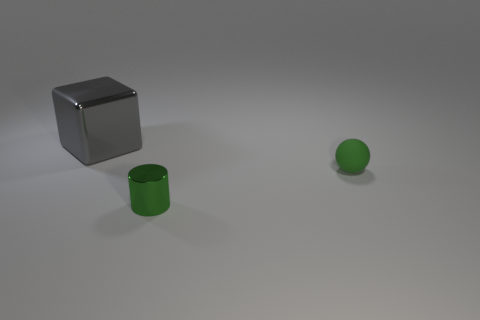Add 2 rubber balls. How many objects exist? 5 Subtract all balls. How many objects are left? 2 Subtract all gray cubes. Subtract all purple things. How many objects are left? 2 Add 2 green balls. How many green balls are left? 3 Add 3 green things. How many green things exist? 5 Subtract 0 red balls. How many objects are left? 3 Subtract all cyan cylinders. Subtract all gray spheres. How many cylinders are left? 1 